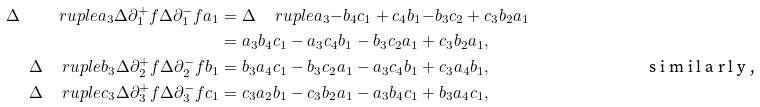<formula> <loc_0><loc_0><loc_500><loc_500>\Delta \, \quad r u p l e { a _ { 3 } } { \Delta \partial ^ { + } _ { 1 } f } { \Delta \partial ^ { - } _ { 1 } f } { a _ { 1 } } & = \Delta \, \quad r u p l e { a _ { 3 } } { - b _ { 4 } c _ { 1 } + c _ { 4 } b _ { 1 } } { - b _ { 3 } c _ { 2 } + c _ { 3 } b _ { 2 } } { a _ { 1 } } \\ & = a _ { 3 } b _ { 4 } c _ { 1 } - a _ { 3 } c _ { 4 } b _ { 1 } - b _ { 3 } c _ { 2 } a _ { 1 } + c _ { 3 } b _ { 2 } a _ { 1 } , \\ \Delta \, \quad r u p l e { b _ { 3 } } { \Delta \partial ^ { + } _ { 2 } f } { \Delta \partial ^ { - } _ { 2 } f } { b _ { 1 } } & = b _ { 3 } a _ { 4 } c _ { 1 } - b _ { 3 } c _ { 2 } a _ { 1 } - a _ { 3 } c _ { 4 } b _ { 1 } + c _ { 3 } a _ { 4 } b _ { 1 } , \tag* { s i m i l a r l y , } \\ \Delta \, \quad r u p l e { c _ { 3 } } { \Delta \partial ^ { + } _ { 3 } f } { \Delta \partial ^ { - } _ { 3 } f } { c _ { 1 } } & = c _ { 3 } a _ { 2 } b _ { 1 } - c _ { 3 } b _ { 2 } a _ { 1 } - a _ { 3 } b _ { 4 } c _ { 1 } + b _ { 3 } a _ { 4 } c _ { 1 } ,</formula> 